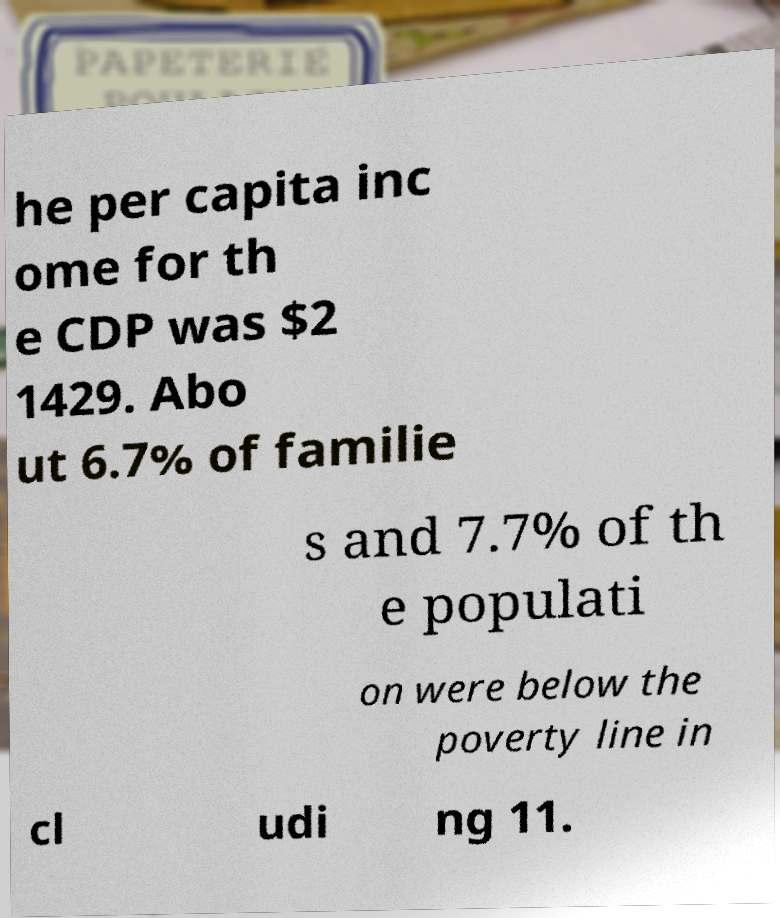There's text embedded in this image that I need extracted. Can you transcribe it verbatim? he per capita inc ome for th e CDP was $2 1429. Abo ut 6.7% of familie s and 7.7% of th e populati on were below the poverty line in cl udi ng 11. 